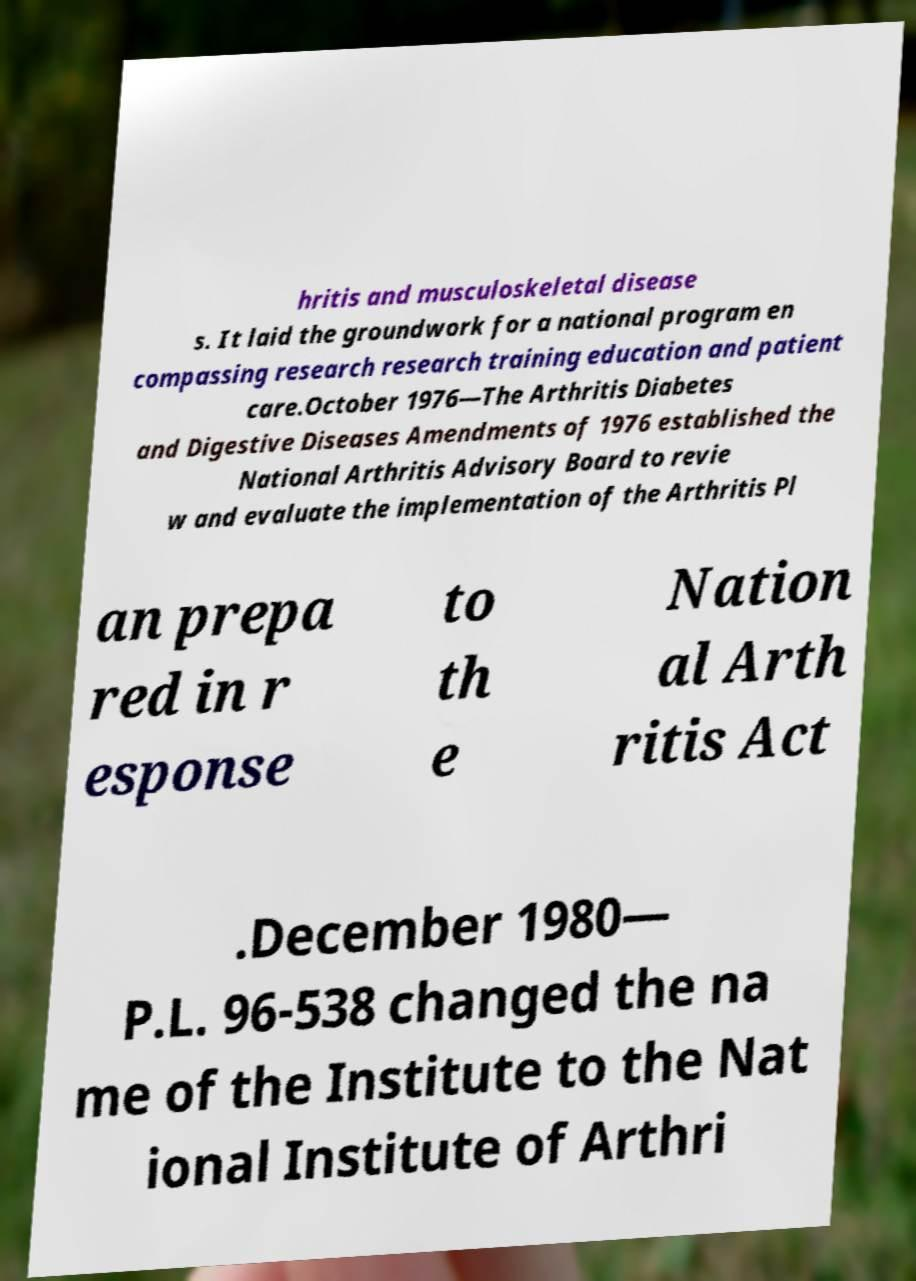Could you assist in decoding the text presented in this image and type it out clearly? hritis and musculoskeletal disease s. It laid the groundwork for a national program en compassing research research training education and patient care.October 1976—The Arthritis Diabetes and Digestive Diseases Amendments of 1976 established the National Arthritis Advisory Board to revie w and evaluate the implementation of the Arthritis Pl an prepa red in r esponse to th e Nation al Arth ritis Act .December 1980— P.L. 96-538 changed the na me of the Institute to the Nat ional Institute of Arthri 